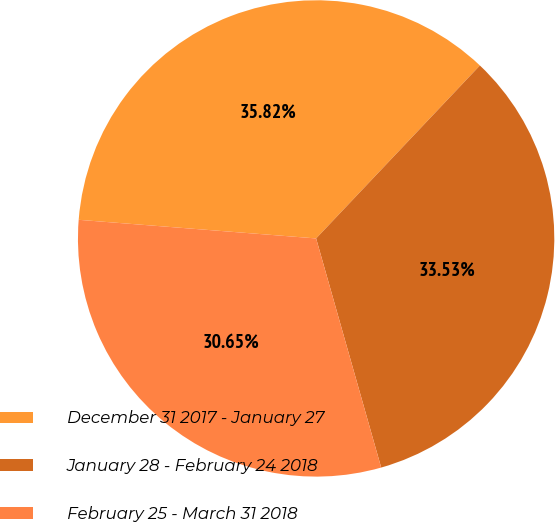Convert chart to OTSL. <chart><loc_0><loc_0><loc_500><loc_500><pie_chart><fcel>December 31 2017 - January 27<fcel>January 28 - February 24 2018<fcel>February 25 - March 31 2018<nl><fcel>35.82%<fcel>33.53%<fcel>30.65%<nl></chart> 